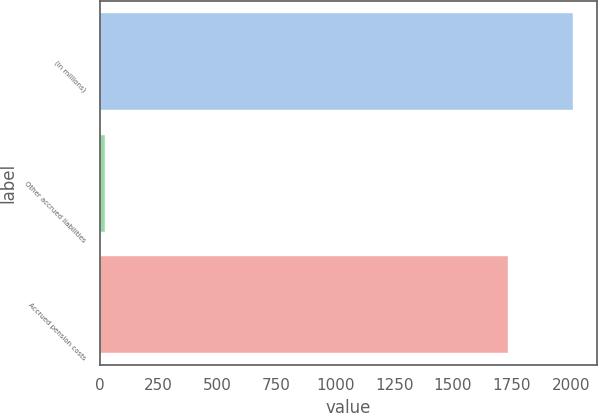Convert chart. <chart><loc_0><loc_0><loc_500><loc_500><bar_chart><fcel>(in millions)<fcel>Other accrued liabilities<fcel>Accrued pension costs<nl><fcel>2012<fcel>22<fcel>1735<nl></chart> 